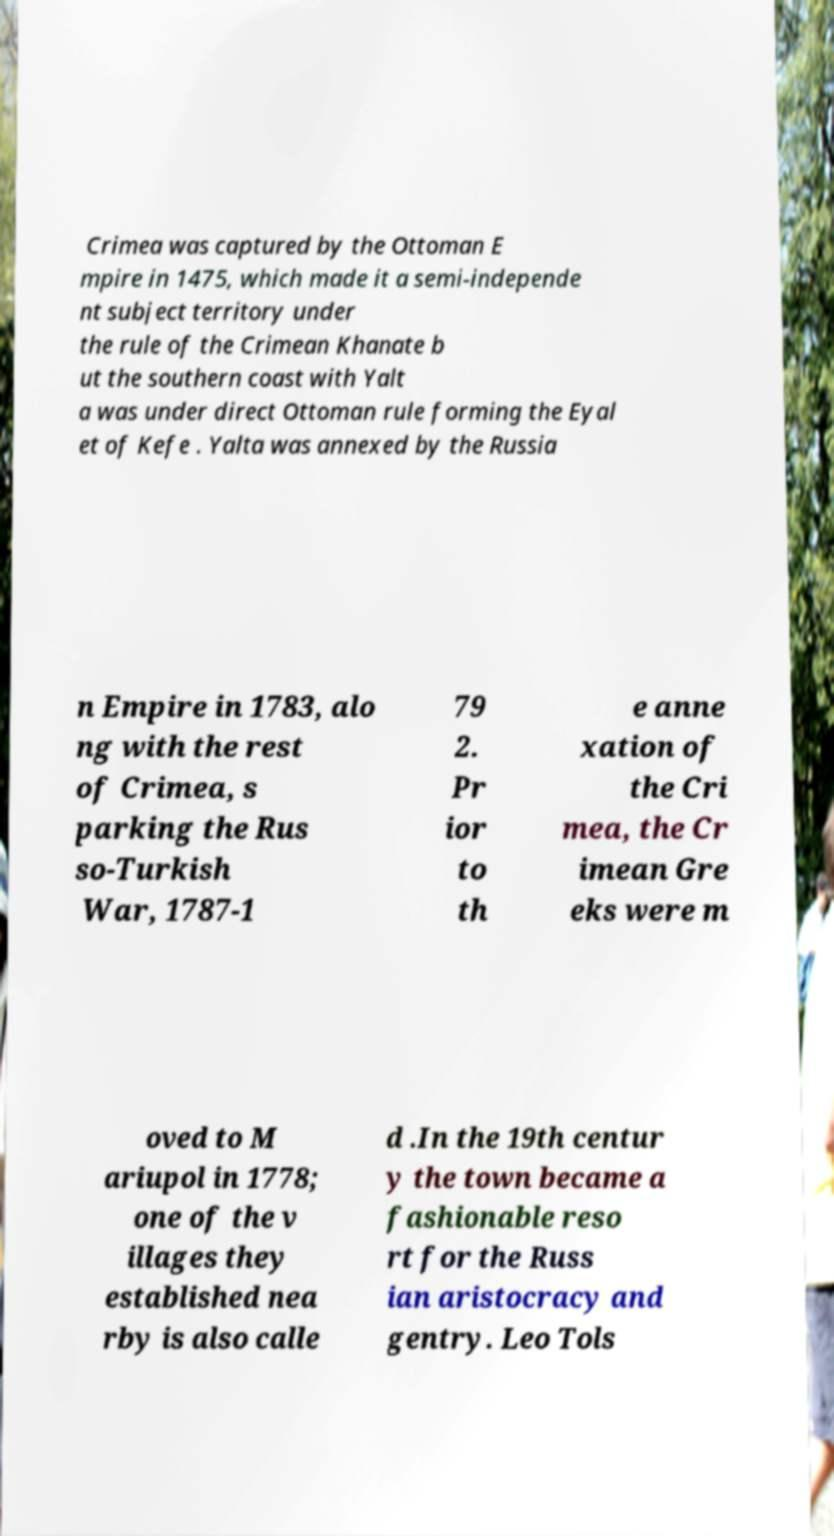Please read and relay the text visible in this image. What does it say? Crimea was captured by the Ottoman E mpire in 1475, which made it a semi-independe nt subject territory under the rule of the Crimean Khanate b ut the southern coast with Yalt a was under direct Ottoman rule forming the Eyal et of Kefe . Yalta was annexed by the Russia n Empire in 1783, alo ng with the rest of Crimea, s parking the Rus so-Turkish War, 1787-1 79 2. Pr ior to th e anne xation of the Cri mea, the Cr imean Gre eks were m oved to M ariupol in 1778; one of the v illages they established nea rby is also calle d .In the 19th centur y the town became a fashionable reso rt for the Russ ian aristocracy and gentry. Leo Tols 